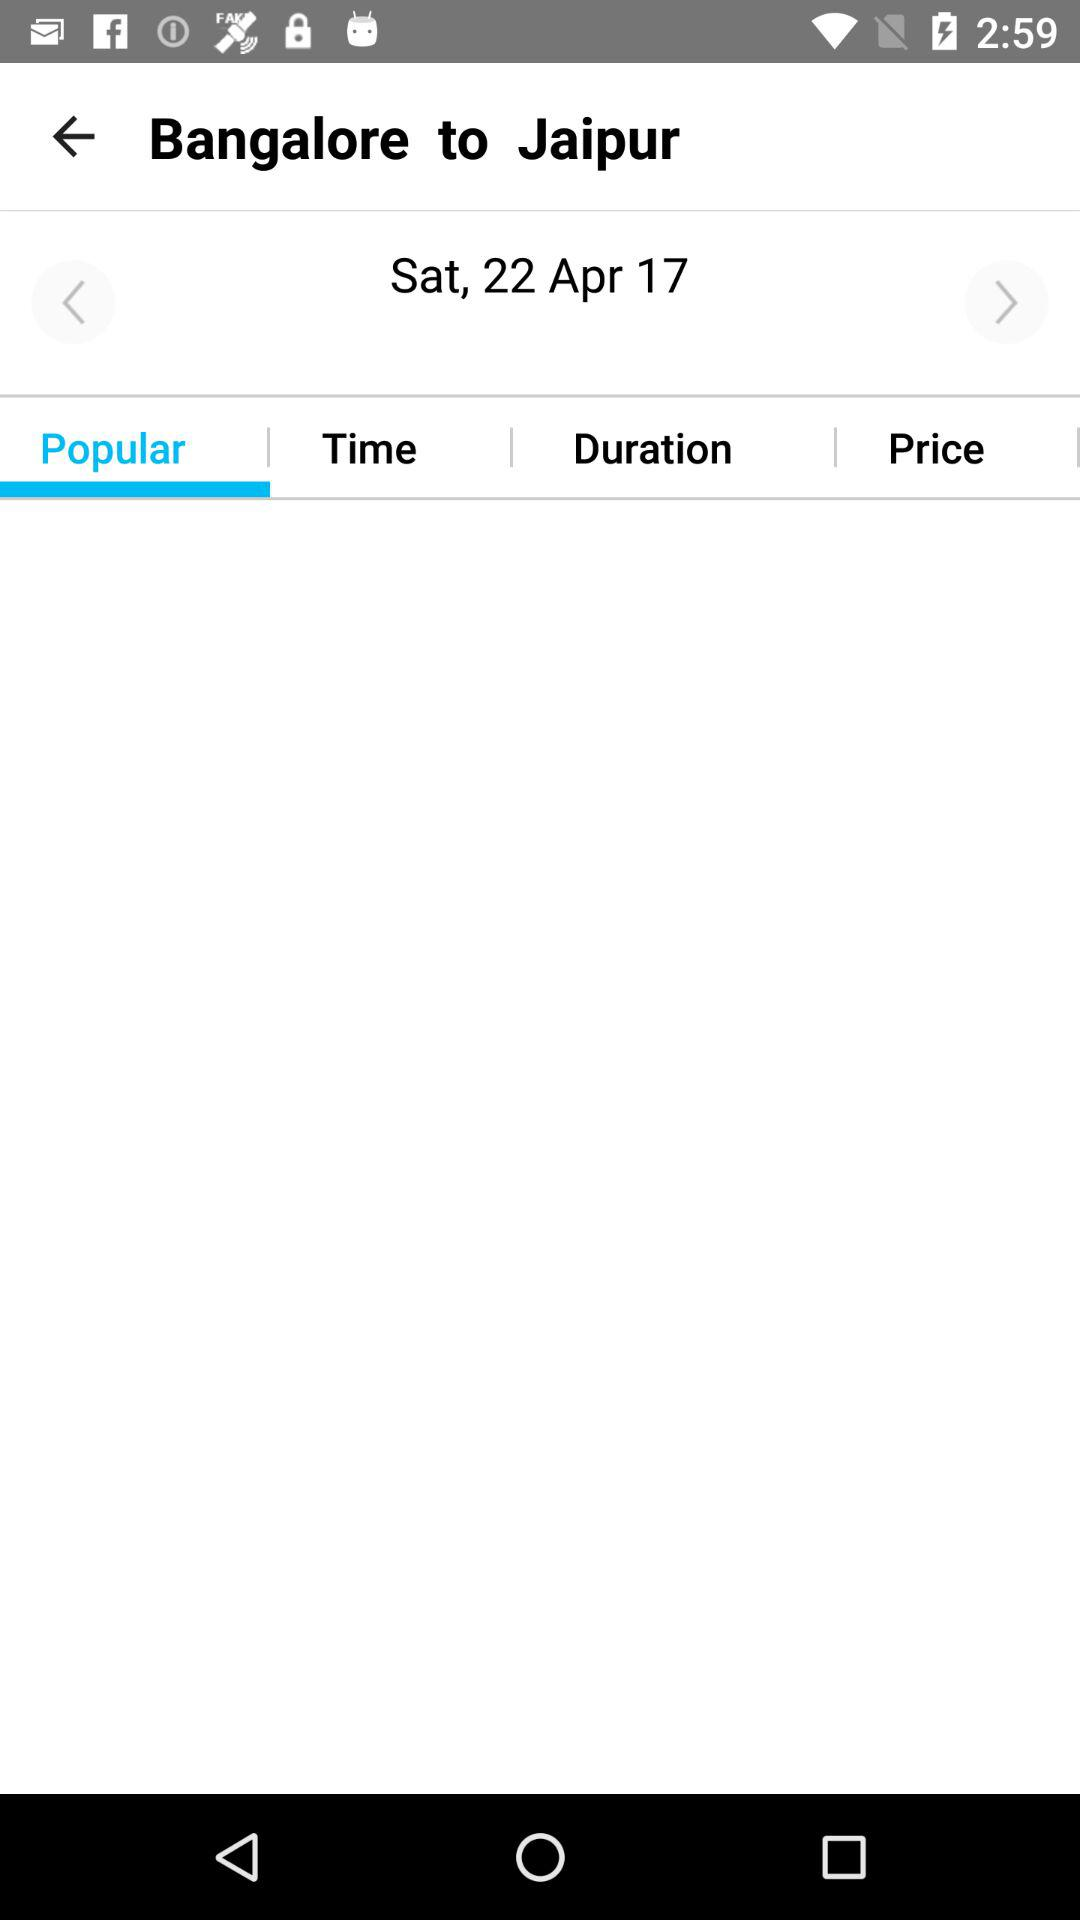What is the selected date? The selected date is Saturday, April 22, 2017. 